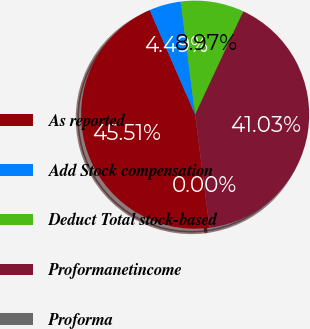<chart> <loc_0><loc_0><loc_500><loc_500><pie_chart><fcel>As reported<fcel>Add Stock compensation<fcel>Deduct Total stock-based<fcel>Proformanetincome<fcel>Proforma<nl><fcel>45.51%<fcel>4.49%<fcel>8.97%<fcel>41.03%<fcel>0.0%<nl></chart> 